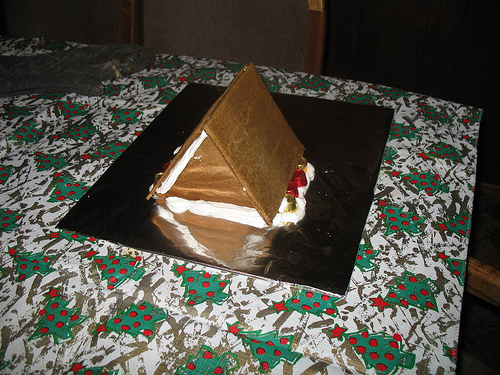<image>
Is the roof on the table? Yes. Looking at the image, I can see the roof is positioned on top of the table, with the table providing support. 